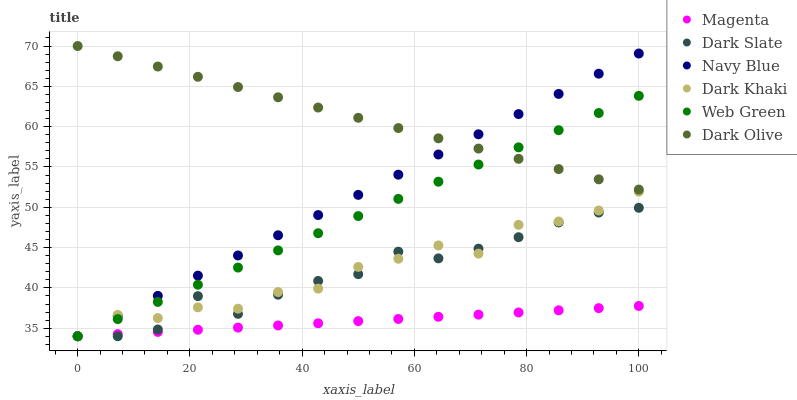Does Magenta have the minimum area under the curve?
Answer yes or no. Yes. Does Dark Olive have the maximum area under the curve?
Answer yes or no. Yes. Does Web Green have the minimum area under the curve?
Answer yes or no. No. Does Web Green have the maximum area under the curve?
Answer yes or no. No. Is Dark Olive the smoothest?
Answer yes or no. Yes. Is Dark Khaki the roughest?
Answer yes or no. Yes. Is Web Green the smoothest?
Answer yes or no. No. Is Web Green the roughest?
Answer yes or no. No. Does Navy Blue have the lowest value?
Answer yes or no. Yes. Does Dark Olive have the lowest value?
Answer yes or no. No. Does Dark Olive have the highest value?
Answer yes or no. Yes. Does Web Green have the highest value?
Answer yes or no. No. Is Magenta less than Dark Olive?
Answer yes or no. Yes. Is Dark Olive greater than Dark Slate?
Answer yes or no. Yes. Does Dark Olive intersect Navy Blue?
Answer yes or no. Yes. Is Dark Olive less than Navy Blue?
Answer yes or no. No. Is Dark Olive greater than Navy Blue?
Answer yes or no. No. Does Magenta intersect Dark Olive?
Answer yes or no. No. 